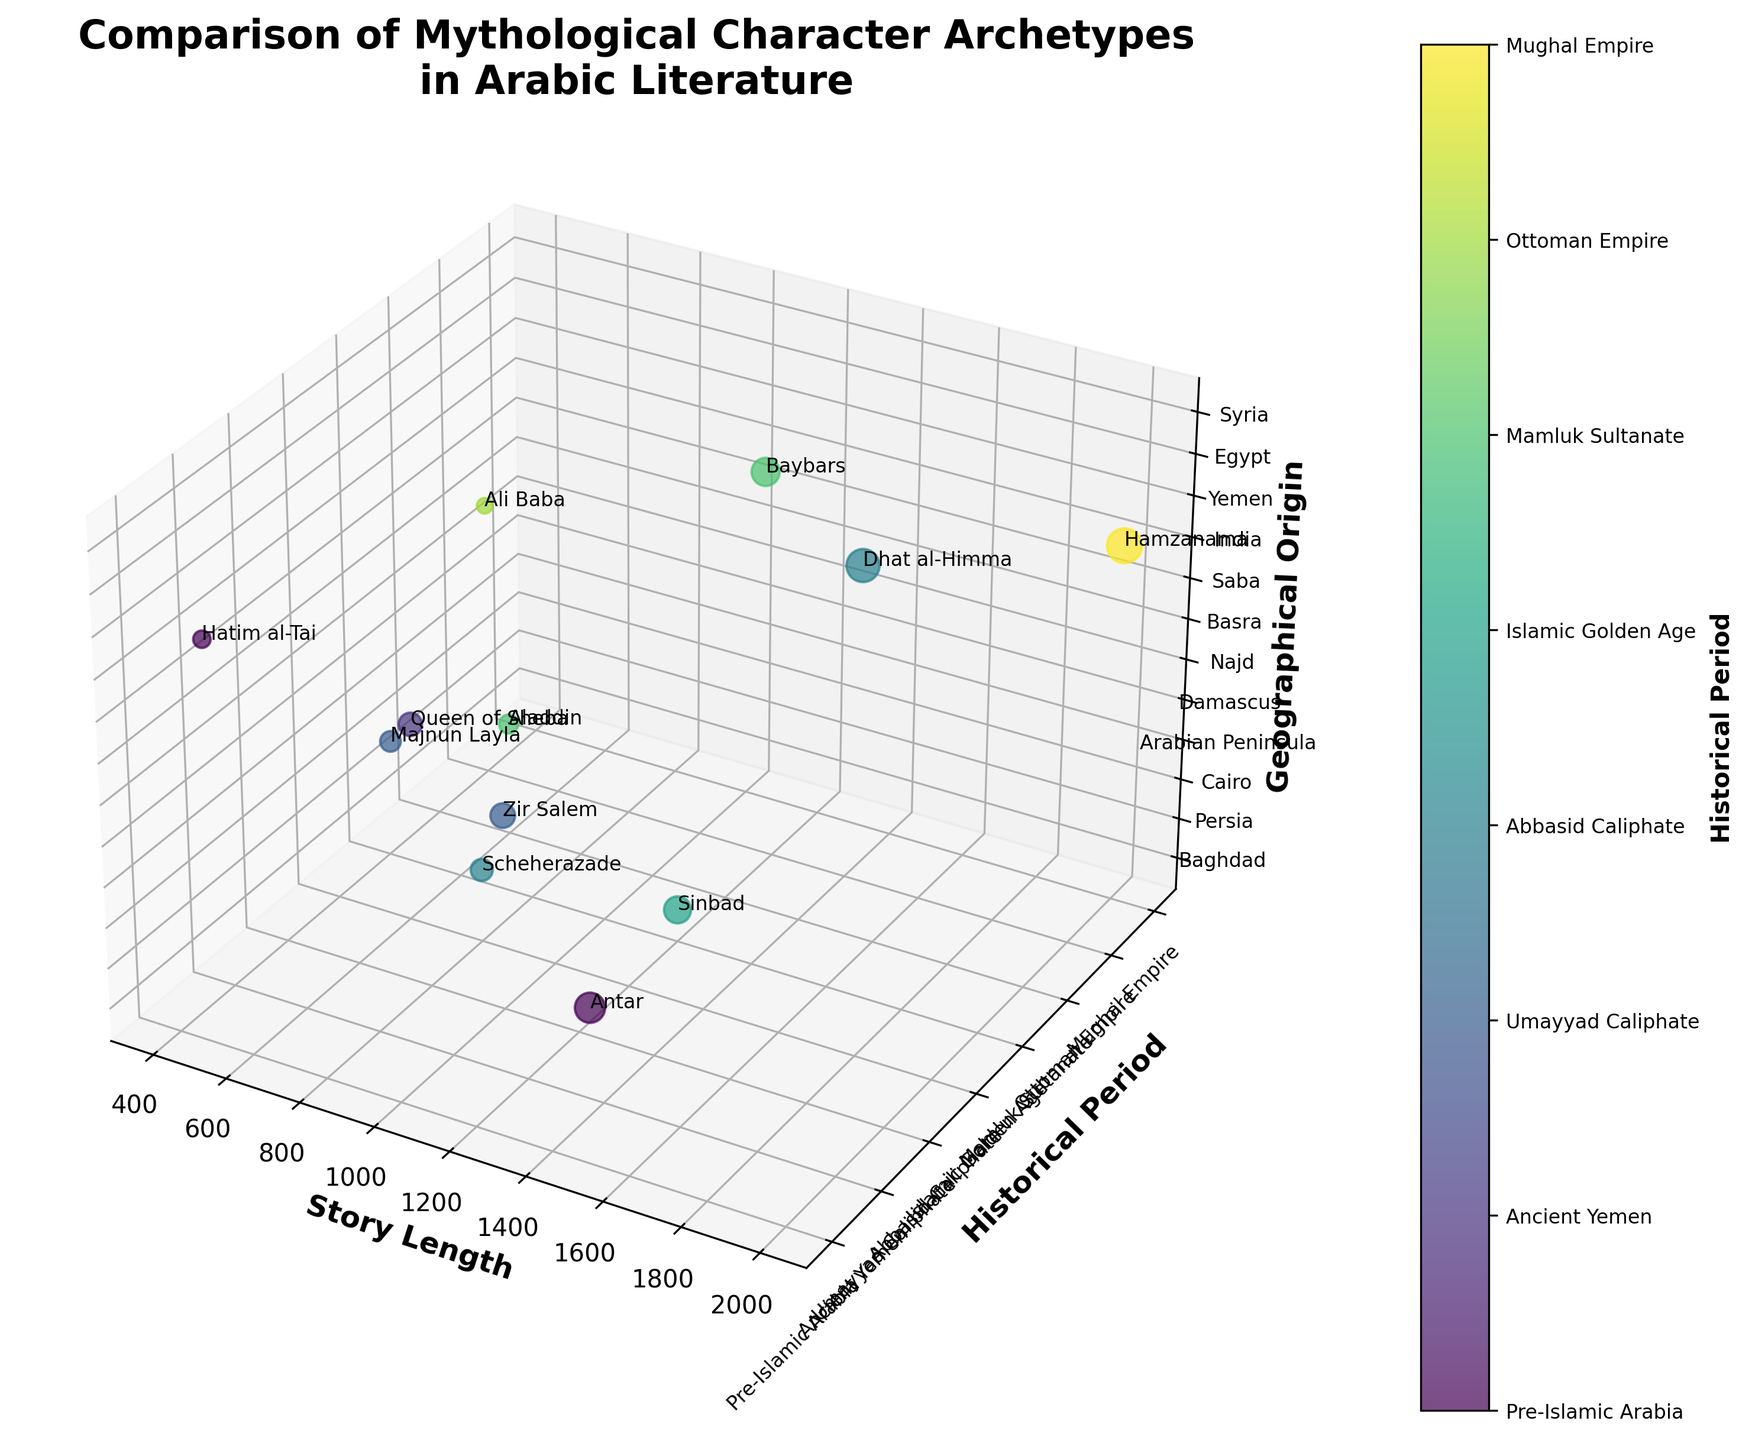What is the title of the plot? The title is usually placed at the top of the plot for easy identification. Here it reads as "Comparison of Mythological Character Archetypes in Arabic Literature".
Answer: Comparison of Mythological Character Archetypes in Arabic Literature How many characters have story lengths over 1,000? Look at the x-axis (Story Length) and count the data points beyond the 1000 mark. There are 5 characters: Sinbad, Antar, Hamzanama, Baybars, and Dhat al-Himma.
Answer: 5 Which historical period has the character with the longest story? Examine the longest story length along the x-axis. The longest story is 2000, corresponding to the Mughal Empire (Hamzanama).
Answer: Mughal Empire (Hamzanama) Which character is associated with the geographical origin "Saba"? Locate the geographical origin "Saba" along the z-axis and find the corresponding character. It is the Queen of Sheba.
Answer: Queen of Sheba What is the average story length for characters from the Abbasid Caliphate? Identify characters belonging to the Abbasid Caliphate from the y-axis. They are Scheherazade (800) and Dhat al-Himma (1800). Calculate their average: (800 + 1800) / 2 = 1300.
Answer: 1300 Which geographical origin has the most mythological characters? Count the number of data points in each geographical origin on the z-axis. Baghdad, Persia, Cairo, Arabian Peninsula, Damascus, Najd, Basra, Saba, India, Yemen, and Egypt all have unique characters. Damascus is repeated twice (Zir Salem and Majnun Layla).
Answer: Damascus Are there any characters from the 'Ottoman Empire' period with a story length less than 500? From the 'Ottoman Empire' historical period on the y-axis, check if the story length is less than 500. Ali Baba has a story length of 400.
Answer: Yes (Ali Baba) Which character from Pre-Islamic Arabia has the shortest story? Observe characters from Pre-Islamic Arabia on the y-axis and compare their story lengths. Hatim al-Tai (500) has the shortest among them.
Answer: Hatim al-Tai How does the story length of 'Majnun Layla' compare to that of 'Aladdin'? Find 'Majnun Layla' (700) and 'Aladdin' (600) on the x-axis and compare. Majnun Layla has a longer story length.
Answer: Majnun Layla is longer 